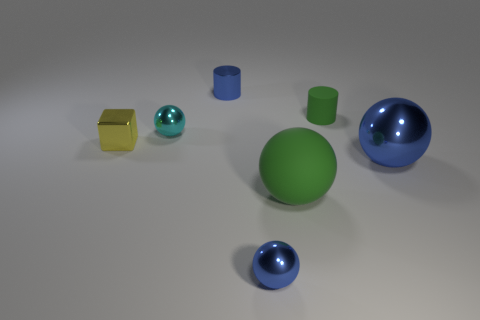What is the material of the other sphere that is the same size as the green ball?
Make the answer very short. Metal. Is there a yellow shiny thing that has the same size as the green rubber cylinder?
Make the answer very short. Yes. Is the size of the blue ball to the left of the matte sphere the same as the big blue object?
Ensure brevity in your answer.  No. The tiny metallic object that is in front of the matte cylinder and on the right side of the small cyan thing has what shape?
Your answer should be compact. Sphere. Is the number of small blue metallic objects on the right side of the cyan ball greater than the number of big green rubber things?
Your response must be concise. Yes. What size is the green sphere that is the same material as the green cylinder?
Make the answer very short. Large. What number of shiny balls have the same color as the tiny metal cylinder?
Your answer should be compact. 2. There is a small metallic ball in front of the metallic cube; is its color the same as the big shiny ball?
Make the answer very short. Yes. Are there an equal number of balls that are on the right side of the large metal object and green rubber objects that are behind the small cyan thing?
Offer a very short reply. No. There is a metallic object that is in front of the big green matte ball; what is its color?
Provide a succinct answer. Blue. 